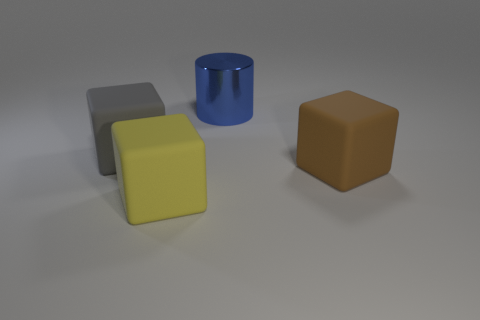Can you describe the materials of the objects? The objects seem to have different matte and slightly reflective surfaces. The cylinder has a shiny, reflective surface indicative of a metallic material, while the cubes have matte finishes that could suggest a plastic or rubber-like material. 